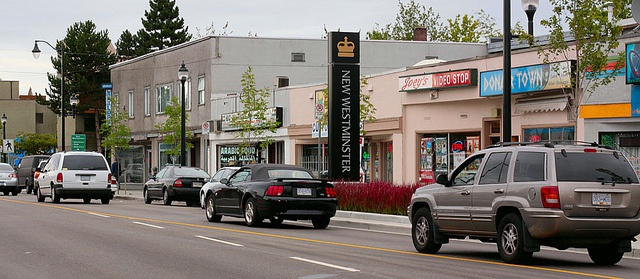Describe the objects in this image and their specific colors. I can see car in lightgray, black, gray, darkgray, and maroon tones, car in lightgray, black, gray, darkgray, and maroon tones, car in lightgray, black, darkgray, and gray tones, car in lightgray, black, darkgray, and gray tones, and car in lightgray, gray, black, and darkgray tones in this image. 